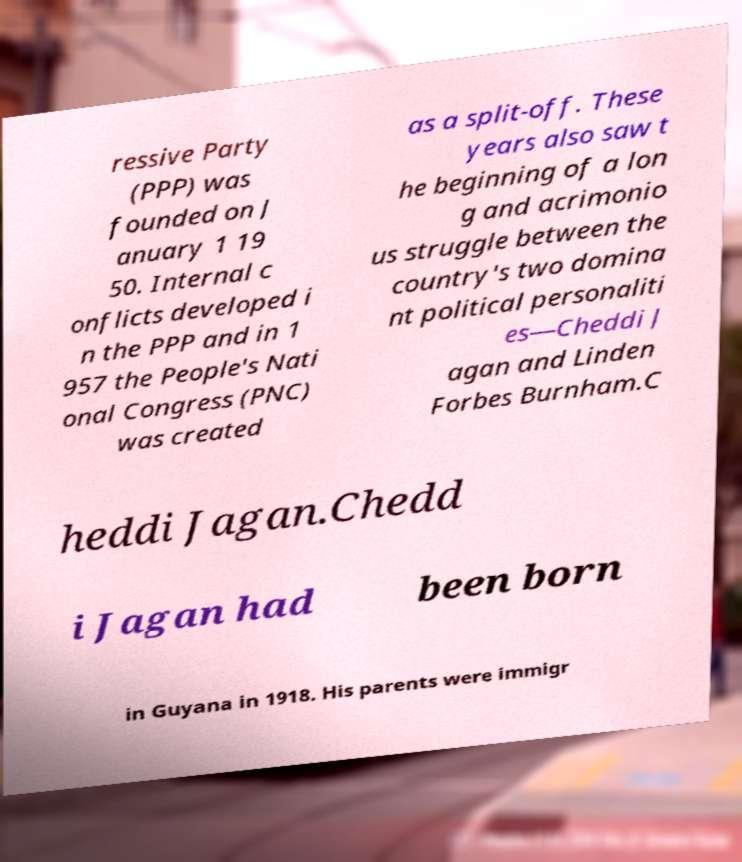For documentation purposes, I need the text within this image transcribed. Could you provide that? ressive Party (PPP) was founded on J anuary 1 19 50. Internal c onflicts developed i n the PPP and in 1 957 the People's Nati onal Congress (PNC) was created as a split-off. These years also saw t he beginning of a lon g and acrimonio us struggle between the country's two domina nt political personaliti es—Cheddi J agan and Linden Forbes Burnham.C heddi Jagan.Chedd i Jagan had been born in Guyana in 1918. His parents were immigr 